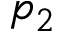<formula> <loc_0><loc_0><loc_500><loc_500>p _ { 2 }</formula> 